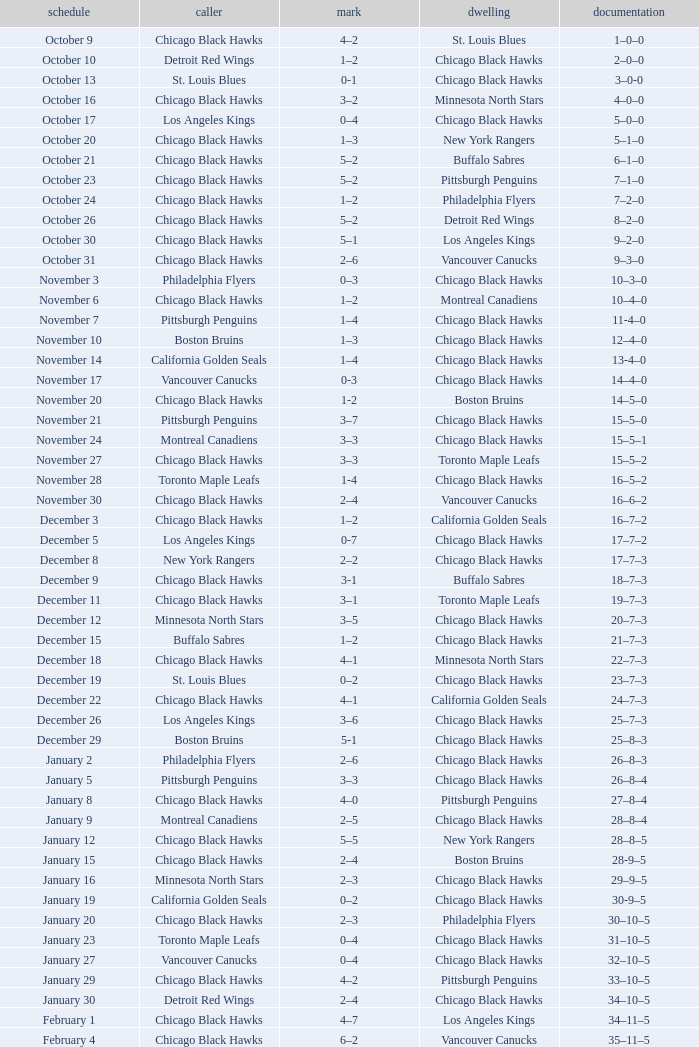What is the Score of the Chicago Black Hawks Home game with the Visiting Vancouver Canucks on November 17? 0-3. 